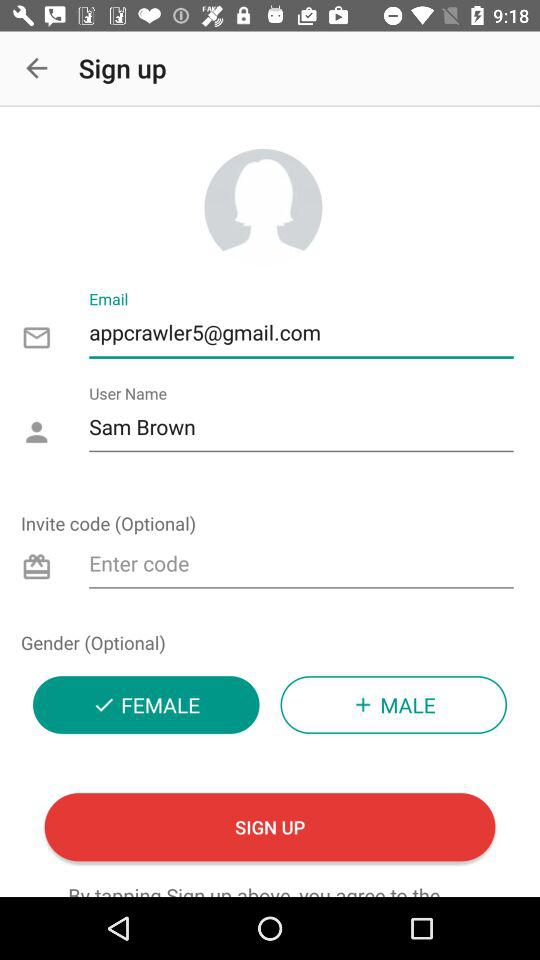What is the name of the user? The name of the user is Sam Brown. 